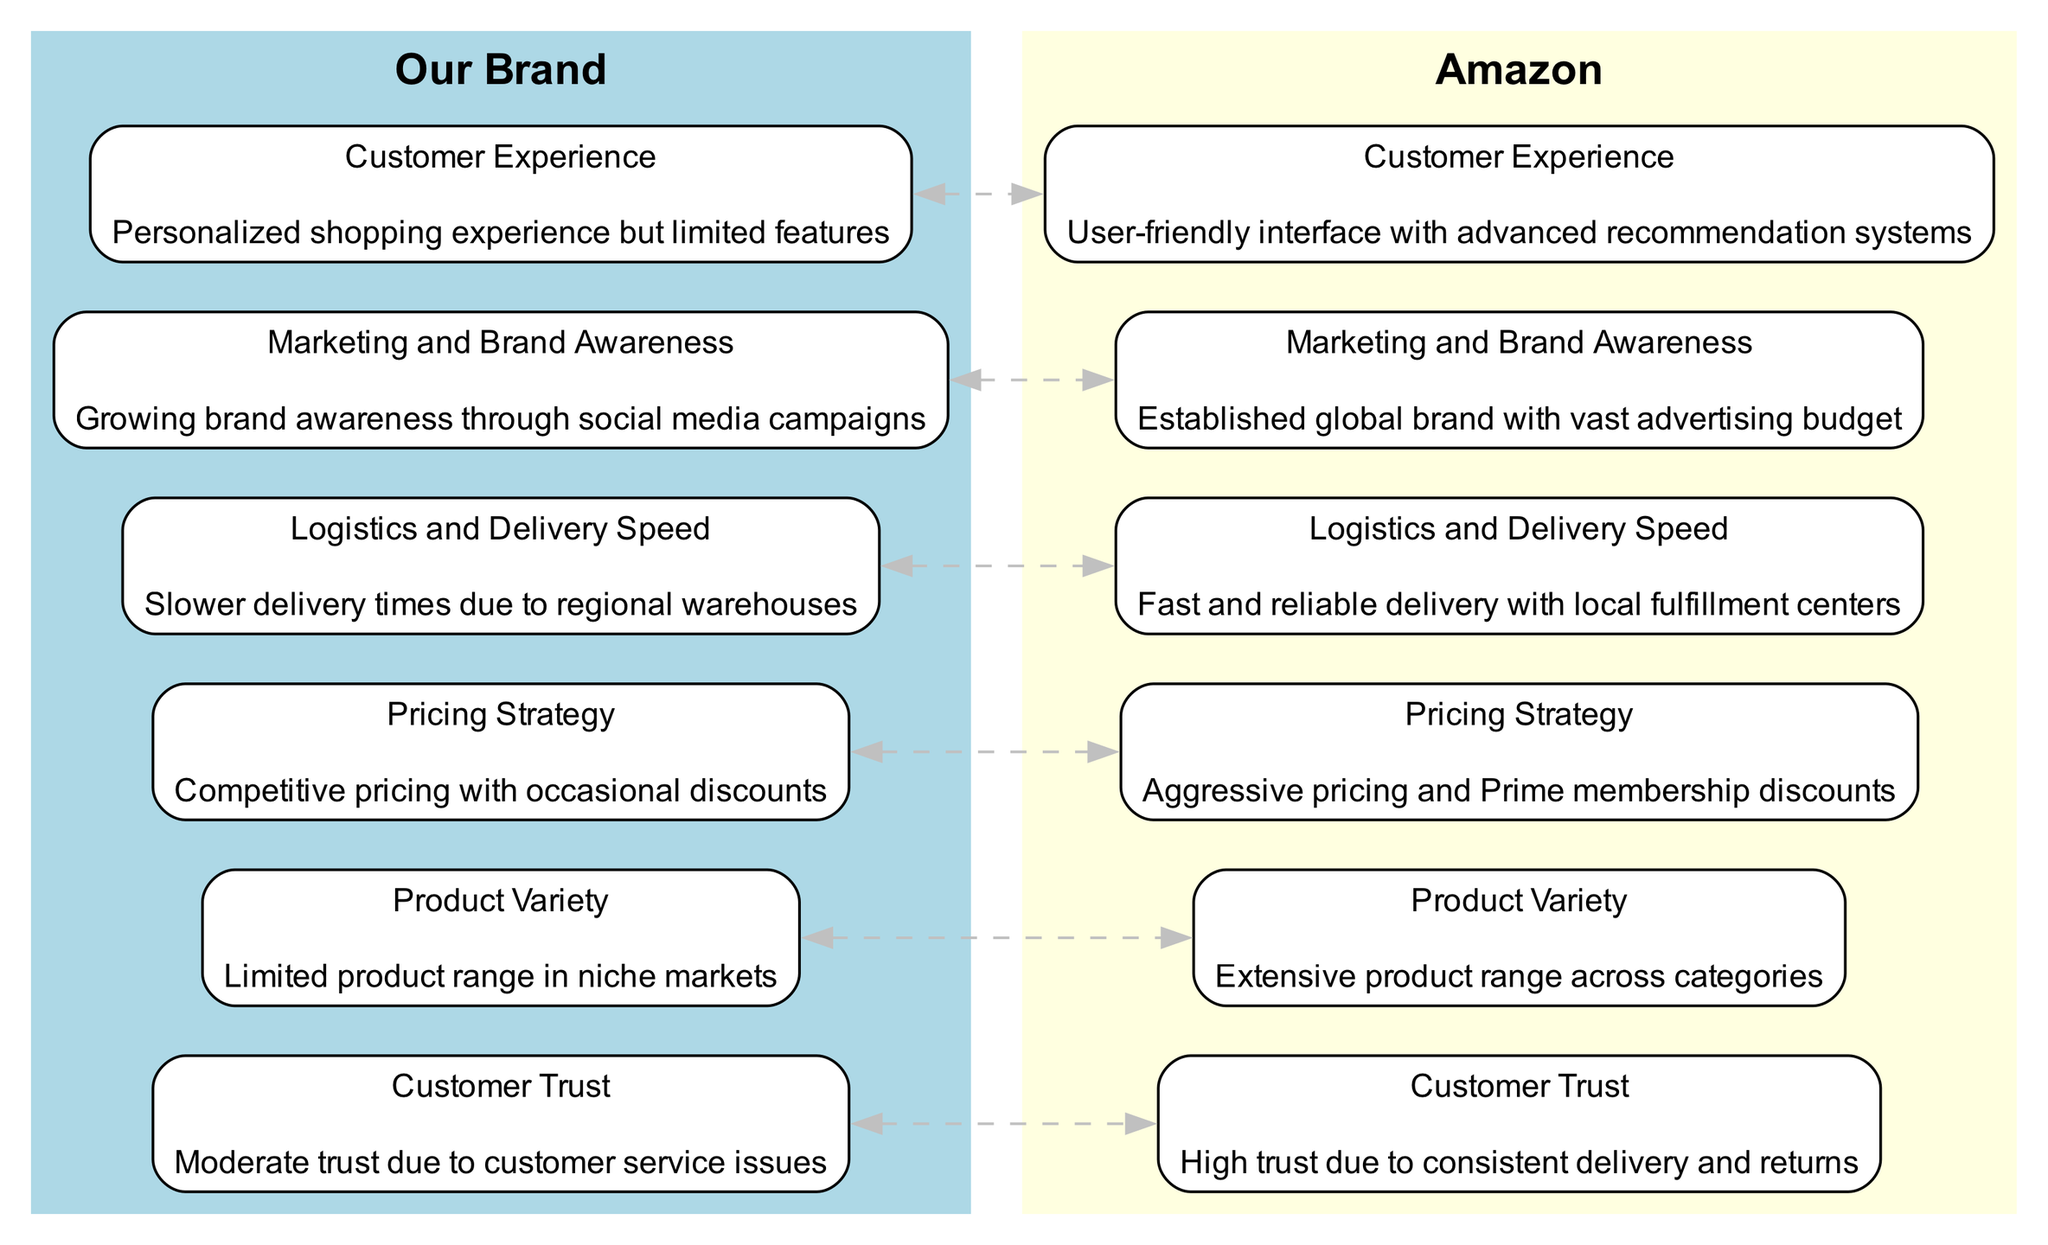What is the customer trust level for Our Brand? The diagram indicates that Our Brand has "Moderate trust due to customer service issues," which is part of the Customer Trust node under Our Brand.
Answer: Moderate trust due to customer service issues What type of product range does Amazon offer? The Product Variety node shows that Amazon has an "Extensive product range across categories," which reflects its broader inventory compared to Our Brand.
Answer: Extensive product range across categories How does Our Brand's pricing strategy compare to Amazon's? The Pricing Strategy node outlines that Our Brand has "Competitive pricing with occasional discounts," while Amazon's strategy is described as "Aggressive pricing and Prime membership discounts," indicating a significant difference in approach.
Answer: Competitive pricing with occasional discounts Which brand has a better logistics and delivery speed? The Logistics and Delivery Speed node illustrates that Our Brand has "Slower delivery times due to regional warehouses," whereas Amazon offers "Fast and reliable delivery with local fulfillment centers," thus Amazon holds the advantage.
Answer: Amazon How many nodes are there in total representing Our Brand? The total number of nodes under Our Brand includes six distinct aspects of the comparison listed in the diagram: Customer Trust, Product Variety, Pricing Strategy, Logistics and Delivery Speed, Marketing and Brand Awareness, and Customer Experience, indicating six nodes in total.
Answer: 6 What is the main focus of Our Brand's marketing efforts? The Marketing and Brand Awareness node states that Our Brand is focused on "Growing brand awareness through social media campaigns," which reflects its current marketing strategy.
Answer: Growing brand awareness through social media campaigns Which company has a user-friendly interface with advanced features? According to the Customer Experience node, Amazon is described as having a "User-friendly interface with advanced recommendation systems," indicating a superior experience for its customers compared to Our Brand.
Answer: User-friendly interface with advanced recommendation systems How are the relationships shown in the diagram between Our Brand and Amazon? The edges between the nodes show a bidirectional comparison (represented as dashed gray lines), indicating that both brands directly relate to each other across all key performance metrics listed in the diagram.
Answer: Bidirectional comparison What is the color used to represent Amazon in the diagram? The diagram specifies that Amazon is represented in a "lightyellow" color, differentiating it visually from Our Brand and indicating its distinct positioning in the graph.
Answer: lightyellow 